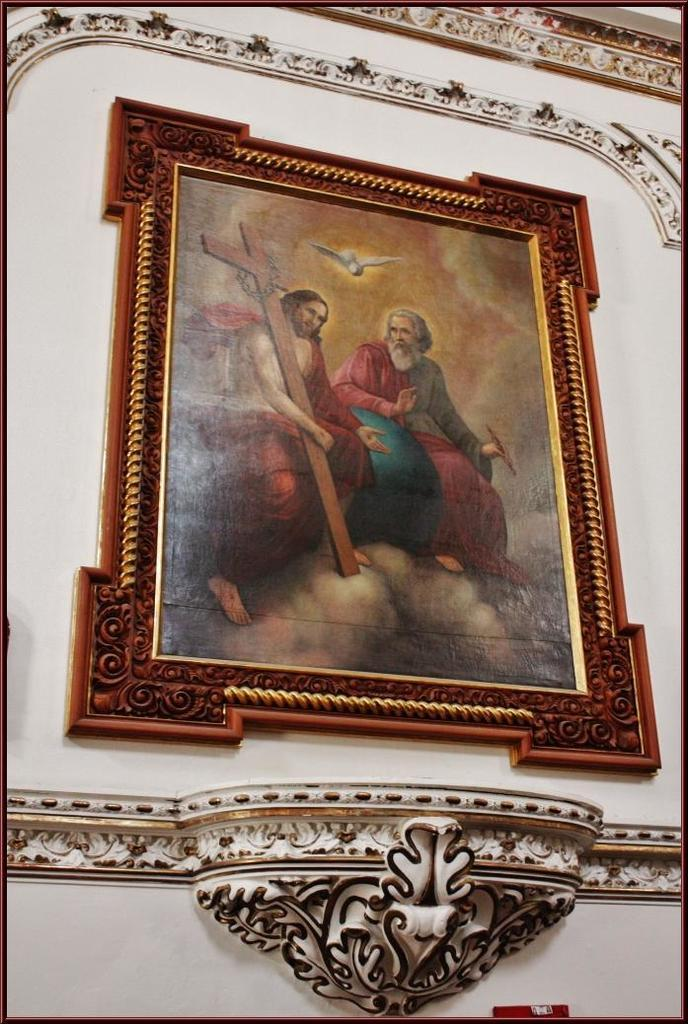What is the color of the photo frame in the image? The photo frame in the image is brown. What is the color of the wall to which the photo frame is attached? The wall to which the photo frame is attached is white. What type of band is playing music in the image? There is no band present in the image; it only features a brown color photo frame attached to a white color wall. 